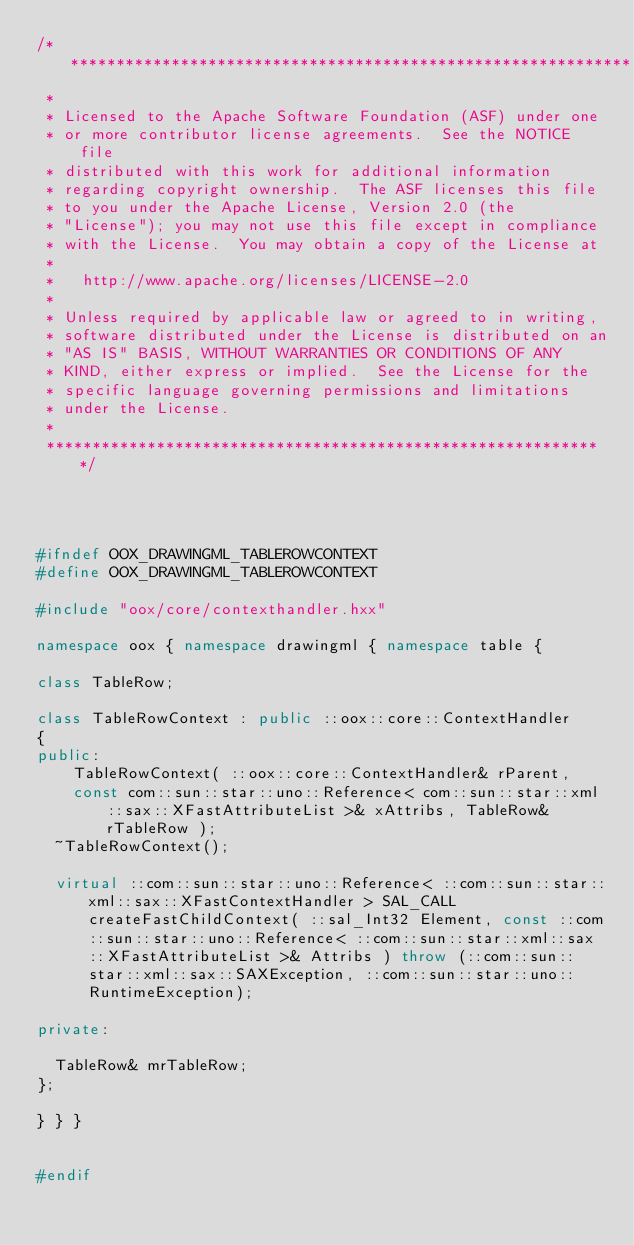Convert code to text. <code><loc_0><loc_0><loc_500><loc_500><_C++_>/**************************************************************
 * 
 * Licensed to the Apache Software Foundation (ASF) under one
 * or more contributor license agreements.  See the NOTICE file
 * distributed with this work for additional information
 * regarding copyright ownership.  The ASF licenses this file
 * to you under the Apache License, Version 2.0 (the
 * "License"); you may not use this file except in compliance
 * with the License.  You may obtain a copy of the License at
 * 
 *   http://www.apache.org/licenses/LICENSE-2.0
 * 
 * Unless required by applicable law or agreed to in writing,
 * software distributed under the License is distributed on an
 * "AS IS" BASIS, WITHOUT WARRANTIES OR CONDITIONS OF ANY
 * KIND, either express or implied.  See the License for the
 * specific language governing permissions and limitations
 * under the License.
 * 
 *************************************************************/




#ifndef OOX_DRAWINGML_TABLEROWCONTEXT
#define OOX_DRAWINGML_TABLEROWCONTEXT

#include "oox/core/contexthandler.hxx"

namespace oox { namespace drawingml { namespace table {

class TableRow;

class TableRowContext : public ::oox::core::ContextHandler
{
public:
    TableRowContext( ::oox::core::ContextHandler& rParent,
		const com::sun::star::uno::Reference< com::sun::star::xml::sax::XFastAttributeList >& xAttribs, TableRow& rTableRow );
	~TableRowContext();

	virtual ::com::sun::star::uno::Reference< ::com::sun::star::xml::sax::XFastContextHandler > SAL_CALL createFastChildContext( ::sal_Int32 Element, const ::com::sun::star::uno::Reference< ::com::sun::star::xml::sax::XFastAttributeList >& Attribs ) throw (::com::sun::star::xml::sax::SAXException, ::com::sun::star::uno::RuntimeException);

private:
	
	TableRow& mrTableRow;
};

} } }


#endif
</code> 